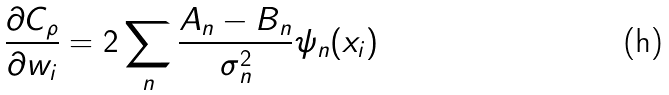<formula> <loc_0><loc_0><loc_500><loc_500>\frac { \partial C _ { \rho } } { \partial w _ { i } } = 2 \sum _ { n } \frac { A _ { n } - B _ { n } } { \sigma _ { n } ^ { 2 } } \psi _ { n } ( x _ { i } )</formula> 